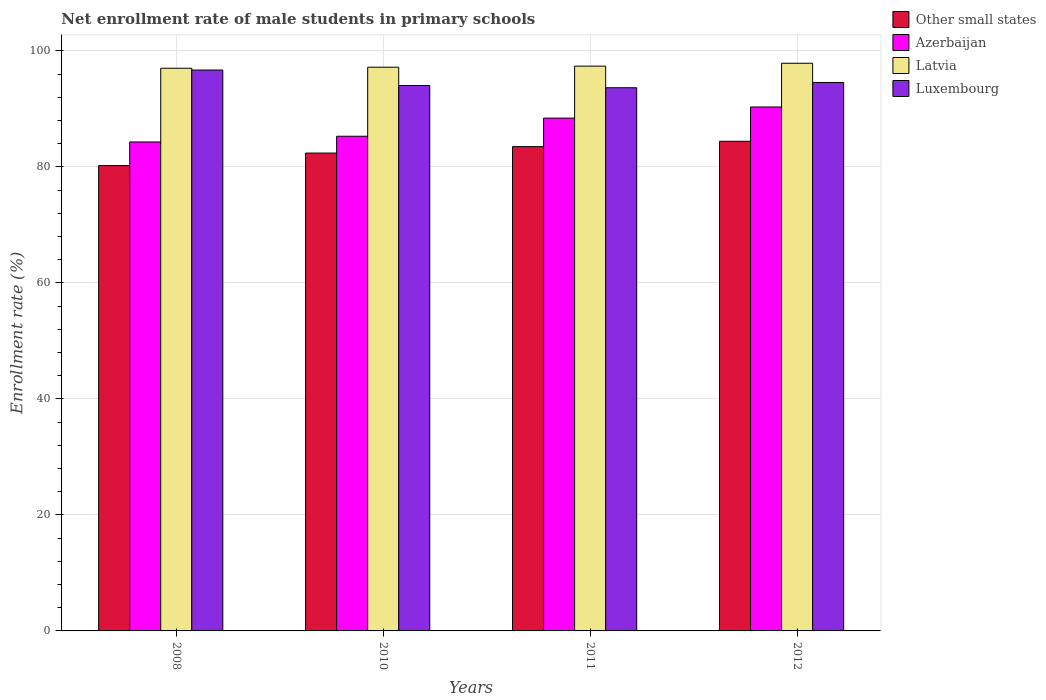How many different coloured bars are there?
Make the answer very short. 4. Are the number of bars per tick equal to the number of legend labels?
Offer a terse response. Yes. How many bars are there on the 2nd tick from the left?
Keep it short and to the point. 4. What is the label of the 2nd group of bars from the left?
Keep it short and to the point. 2010. In how many cases, is the number of bars for a given year not equal to the number of legend labels?
Make the answer very short. 0. What is the net enrollment rate of male students in primary schools in Other small states in 2012?
Offer a terse response. 84.41. Across all years, what is the maximum net enrollment rate of male students in primary schools in Other small states?
Ensure brevity in your answer.  84.41. Across all years, what is the minimum net enrollment rate of male students in primary schools in Azerbaijan?
Offer a very short reply. 84.3. In which year was the net enrollment rate of male students in primary schools in Latvia minimum?
Give a very brief answer. 2008. What is the total net enrollment rate of male students in primary schools in Other small states in the graph?
Keep it short and to the point. 330.5. What is the difference between the net enrollment rate of male students in primary schools in Azerbaijan in 2008 and that in 2010?
Your response must be concise. -0.98. What is the difference between the net enrollment rate of male students in primary schools in Azerbaijan in 2010 and the net enrollment rate of male students in primary schools in Other small states in 2012?
Offer a very short reply. 0.87. What is the average net enrollment rate of male students in primary schools in Luxembourg per year?
Ensure brevity in your answer.  94.73. In the year 2010, what is the difference between the net enrollment rate of male students in primary schools in Azerbaijan and net enrollment rate of male students in primary schools in Other small states?
Your answer should be very brief. 2.9. What is the ratio of the net enrollment rate of male students in primary schools in Azerbaijan in 2008 to that in 2011?
Offer a very short reply. 0.95. Is the net enrollment rate of male students in primary schools in Luxembourg in 2010 less than that in 2011?
Give a very brief answer. No. What is the difference between the highest and the second highest net enrollment rate of male students in primary schools in Other small states?
Ensure brevity in your answer.  0.92. What is the difference between the highest and the lowest net enrollment rate of male students in primary schools in Latvia?
Your answer should be very brief. 0.86. In how many years, is the net enrollment rate of male students in primary schools in Luxembourg greater than the average net enrollment rate of male students in primary schools in Luxembourg taken over all years?
Keep it short and to the point. 1. What does the 4th bar from the left in 2011 represents?
Make the answer very short. Luxembourg. What does the 4th bar from the right in 2011 represents?
Your response must be concise. Other small states. Is it the case that in every year, the sum of the net enrollment rate of male students in primary schools in Latvia and net enrollment rate of male students in primary schools in Other small states is greater than the net enrollment rate of male students in primary schools in Azerbaijan?
Your answer should be very brief. Yes. How many years are there in the graph?
Offer a very short reply. 4. What is the difference between two consecutive major ticks on the Y-axis?
Provide a succinct answer. 20. Does the graph contain any zero values?
Provide a succinct answer. No. Does the graph contain grids?
Give a very brief answer. Yes. How are the legend labels stacked?
Provide a succinct answer. Vertical. What is the title of the graph?
Ensure brevity in your answer.  Net enrollment rate of male students in primary schools. What is the label or title of the Y-axis?
Your answer should be compact. Enrollment rate (%). What is the Enrollment rate (%) of Other small states in 2008?
Make the answer very short. 80.22. What is the Enrollment rate (%) of Azerbaijan in 2008?
Your answer should be compact. 84.3. What is the Enrollment rate (%) of Latvia in 2008?
Offer a very short reply. 97. What is the Enrollment rate (%) in Luxembourg in 2008?
Offer a terse response. 96.69. What is the Enrollment rate (%) in Other small states in 2010?
Keep it short and to the point. 82.38. What is the Enrollment rate (%) of Azerbaijan in 2010?
Your answer should be very brief. 85.28. What is the Enrollment rate (%) of Latvia in 2010?
Provide a short and direct response. 97.18. What is the Enrollment rate (%) in Luxembourg in 2010?
Your response must be concise. 94.03. What is the Enrollment rate (%) of Other small states in 2011?
Keep it short and to the point. 83.49. What is the Enrollment rate (%) of Azerbaijan in 2011?
Ensure brevity in your answer.  88.41. What is the Enrollment rate (%) of Latvia in 2011?
Ensure brevity in your answer.  97.37. What is the Enrollment rate (%) in Luxembourg in 2011?
Your answer should be compact. 93.64. What is the Enrollment rate (%) of Other small states in 2012?
Keep it short and to the point. 84.41. What is the Enrollment rate (%) in Azerbaijan in 2012?
Provide a succinct answer. 90.33. What is the Enrollment rate (%) in Latvia in 2012?
Offer a very short reply. 97.86. What is the Enrollment rate (%) of Luxembourg in 2012?
Your answer should be compact. 94.55. Across all years, what is the maximum Enrollment rate (%) of Other small states?
Give a very brief answer. 84.41. Across all years, what is the maximum Enrollment rate (%) of Azerbaijan?
Your answer should be very brief. 90.33. Across all years, what is the maximum Enrollment rate (%) of Latvia?
Your answer should be compact. 97.86. Across all years, what is the maximum Enrollment rate (%) in Luxembourg?
Your response must be concise. 96.69. Across all years, what is the minimum Enrollment rate (%) of Other small states?
Offer a very short reply. 80.22. Across all years, what is the minimum Enrollment rate (%) in Azerbaijan?
Provide a short and direct response. 84.3. Across all years, what is the minimum Enrollment rate (%) of Latvia?
Your answer should be compact. 97. Across all years, what is the minimum Enrollment rate (%) of Luxembourg?
Your response must be concise. 93.64. What is the total Enrollment rate (%) of Other small states in the graph?
Ensure brevity in your answer.  330.5. What is the total Enrollment rate (%) in Azerbaijan in the graph?
Provide a short and direct response. 348.31. What is the total Enrollment rate (%) of Latvia in the graph?
Your answer should be very brief. 389.42. What is the total Enrollment rate (%) of Luxembourg in the graph?
Your answer should be very brief. 378.91. What is the difference between the Enrollment rate (%) in Other small states in 2008 and that in 2010?
Your answer should be compact. -2.16. What is the difference between the Enrollment rate (%) in Azerbaijan in 2008 and that in 2010?
Your answer should be compact. -0.98. What is the difference between the Enrollment rate (%) in Latvia in 2008 and that in 2010?
Ensure brevity in your answer.  -0.18. What is the difference between the Enrollment rate (%) in Luxembourg in 2008 and that in 2010?
Offer a very short reply. 2.66. What is the difference between the Enrollment rate (%) in Other small states in 2008 and that in 2011?
Give a very brief answer. -3.27. What is the difference between the Enrollment rate (%) in Azerbaijan in 2008 and that in 2011?
Make the answer very short. -4.11. What is the difference between the Enrollment rate (%) of Latvia in 2008 and that in 2011?
Make the answer very short. -0.36. What is the difference between the Enrollment rate (%) in Luxembourg in 2008 and that in 2011?
Your answer should be very brief. 3.05. What is the difference between the Enrollment rate (%) of Other small states in 2008 and that in 2012?
Your answer should be very brief. -4.2. What is the difference between the Enrollment rate (%) in Azerbaijan in 2008 and that in 2012?
Offer a terse response. -6.03. What is the difference between the Enrollment rate (%) of Latvia in 2008 and that in 2012?
Provide a short and direct response. -0.86. What is the difference between the Enrollment rate (%) of Luxembourg in 2008 and that in 2012?
Provide a succinct answer. 2.14. What is the difference between the Enrollment rate (%) in Other small states in 2010 and that in 2011?
Keep it short and to the point. -1.11. What is the difference between the Enrollment rate (%) of Azerbaijan in 2010 and that in 2011?
Give a very brief answer. -3.13. What is the difference between the Enrollment rate (%) of Latvia in 2010 and that in 2011?
Your response must be concise. -0.19. What is the difference between the Enrollment rate (%) of Luxembourg in 2010 and that in 2011?
Give a very brief answer. 0.39. What is the difference between the Enrollment rate (%) of Other small states in 2010 and that in 2012?
Offer a very short reply. -2.03. What is the difference between the Enrollment rate (%) in Azerbaijan in 2010 and that in 2012?
Make the answer very short. -5.05. What is the difference between the Enrollment rate (%) in Latvia in 2010 and that in 2012?
Keep it short and to the point. -0.68. What is the difference between the Enrollment rate (%) in Luxembourg in 2010 and that in 2012?
Offer a terse response. -0.52. What is the difference between the Enrollment rate (%) in Other small states in 2011 and that in 2012?
Make the answer very short. -0.92. What is the difference between the Enrollment rate (%) in Azerbaijan in 2011 and that in 2012?
Provide a short and direct response. -1.92. What is the difference between the Enrollment rate (%) of Latvia in 2011 and that in 2012?
Your response must be concise. -0.5. What is the difference between the Enrollment rate (%) in Luxembourg in 2011 and that in 2012?
Keep it short and to the point. -0.91. What is the difference between the Enrollment rate (%) in Other small states in 2008 and the Enrollment rate (%) in Azerbaijan in 2010?
Give a very brief answer. -5.06. What is the difference between the Enrollment rate (%) in Other small states in 2008 and the Enrollment rate (%) in Latvia in 2010?
Make the answer very short. -16.96. What is the difference between the Enrollment rate (%) in Other small states in 2008 and the Enrollment rate (%) in Luxembourg in 2010?
Give a very brief answer. -13.81. What is the difference between the Enrollment rate (%) in Azerbaijan in 2008 and the Enrollment rate (%) in Latvia in 2010?
Make the answer very short. -12.89. What is the difference between the Enrollment rate (%) in Azerbaijan in 2008 and the Enrollment rate (%) in Luxembourg in 2010?
Your response must be concise. -9.73. What is the difference between the Enrollment rate (%) in Latvia in 2008 and the Enrollment rate (%) in Luxembourg in 2010?
Provide a succinct answer. 2.97. What is the difference between the Enrollment rate (%) in Other small states in 2008 and the Enrollment rate (%) in Azerbaijan in 2011?
Your response must be concise. -8.19. What is the difference between the Enrollment rate (%) of Other small states in 2008 and the Enrollment rate (%) of Latvia in 2011?
Make the answer very short. -17.15. What is the difference between the Enrollment rate (%) in Other small states in 2008 and the Enrollment rate (%) in Luxembourg in 2011?
Keep it short and to the point. -13.42. What is the difference between the Enrollment rate (%) of Azerbaijan in 2008 and the Enrollment rate (%) of Latvia in 2011?
Your answer should be compact. -13.07. What is the difference between the Enrollment rate (%) of Azerbaijan in 2008 and the Enrollment rate (%) of Luxembourg in 2011?
Provide a succinct answer. -9.35. What is the difference between the Enrollment rate (%) of Latvia in 2008 and the Enrollment rate (%) of Luxembourg in 2011?
Offer a terse response. 3.36. What is the difference between the Enrollment rate (%) of Other small states in 2008 and the Enrollment rate (%) of Azerbaijan in 2012?
Provide a succinct answer. -10.11. What is the difference between the Enrollment rate (%) in Other small states in 2008 and the Enrollment rate (%) in Latvia in 2012?
Your answer should be very brief. -17.64. What is the difference between the Enrollment rate (%) in Other small states in 2008 and the Enrollment rate (%) in Luxembourg in 2012?
Provide a succinct answer. -14.33. What is the difference between the Enrollment rate (%) of Azerbaijan in 2008 and the Enrollment rate (%) of Latvia in 2012?
Give a very brief answer. -13.57. What is the difference between the Enrollment rate (%) in Azerbaijan in 2008 and the Enrollment rate (%) in Luxembourg in 2012?
Your answer should be compact. -10.25. What is the difference between the Enrollment rate (%) in Latvia in 2008 and the Enrollment rate (%) in Luxembourg in 2012?
Offer a very short reply. 2.46. What is the difference between the Enrollment rate (%) in Other small states in 2010 and the Enrollment rate (%) in Azerbaijan in 2011?
Your answer should be compact. -6.02. What is the difference between the Enrollment rate (%) in Other small states in 2010 and the Enrollment rate (%) in Latvia in 2011?
Give a very brief answer. -14.99. What is the difference between the Enrollment rate (%) of Other small states in 2010 and the Enrollment rate (%) of Luxembourg in 2011?
Your answer should be compact. -11.26. What is the difference between the Enrollment rate (%) in Azerbaijan in 2010 and the Enrollment rate (%) in Latvia in 2011?
Provide a succinct answer. -12.09. What is the difference between the Enrollment rate (%) of Azerbaijan in 2010 and the Enrollment rate (%) of Luxembourg in 2011?
Your answer should be very brief. -8.36. What is the difference between the Enrollment rate (%) of Latvia in 2010 and the Enrollment rate (%) of Luxembourg in 2011?
Your answer should be compact. 3.54. What is the difference between the Enrollment rate (%) in Other small states in 2010 and the Enrollment rate (%) in Azerbaijan in 2012?
Your answer should be very brief. -7.94. What is the difference between the Enrollment rate (%) in Other small states in 2010 and the Enrollment rate (%) in Latvia in 2012?
Your response must be concise. -15.48. What is the difference between the Enrollment rate (%) of Other small states in 2010 and the Enrollment rate (%) of Luxembourg in 2012?
Your response must be concise. -12.17. What is the difference between the Enrollment rate (%) in Azerbaijan in 2010 and the Enrollment rate (%) in Latvia in 2012?
Offer a terse response. -12.58. What is the difference between the Enrollment rate (%) in Azerbaijan in 2010 and the Enrollment rate (%) in Luxembourg in 2012?
Give a very brief answer. -9.27. What is the difference between the Enrollment rate (%) in Latvia in 2010 and the Enrollment rate (%) in Luxembourg in 2012?
Your answer should be compact. 2.63. What is the difference between the Enrollment rate (%) in Other small states in 2011 and the Enrollment rate (%) in Azerbaijan in 2012?
Keep it short and to the point. -6.83. What is the difference between the Enrollment rate (%) in Other small states in 2011 and the Enrollment rate (%) in Latvia in 2012?
Your answer should be very brief. -14.37. What is the difference between the Enrollment rate (%) in Other small states in 2011 and the Enrollment rate (%) in Luxembourg in 2012?
Provide a short and direct response. -11.06. What is the difference between the Enrollment rate (%) in Azerbaijan in 2011 and the Enrollment rate (%) in Latvia in 2012?
Offer a terse response. -9.46. What is the difference between the Enrollment rate (%) of Azerbaijan in 2011 and the Enrollment rate (%) of Luxembourg in 2012?
Offer a very short reply. -6.14. What is the difference between the Enrollment rate (%) in Latvia in 2011 and the Enrollment rate (%) in Luxembourg in 2012?
Give a very brief answer. 2.82. What is the average Enrollment rate (%) in Other small states per year?
Your answer should be very brief. 82.63. What is the average Enrollment rate (%) of Azerbaijan per year?
Provide a succinct answer. 87.08. What is the average Enrollment rate (%) in Latvia per year?
Your answer should be compact. 97.35. What is the average Enrollment rate (%) of Luxembourg per year?
Give a very brief answer. 94.73. In the year 2008, what is the difference between the Enrollment rate (%) in Other small states and Enrollment rate (%) in Azerbaijan?
Provide a short and direct response. -4.08. In the year 2008, what is the difference between the Enrollment rate (%) of Other small states and Enrollment rate (%) of Latvia?
Make the answer very short. -16.79. In the year 2008, what is the difference between the Enrollment rate (%) in Other small states and Enrollment rate (%) in Luxembourg?
Offer a very short reply. -16.48. In the year 2008, what is the difference between the Enrollment rate (%) of Azerbaijan and Enrollment rate (%) of Latvia?
Offer a very short reply. -12.71. In the year 2008, what is the difference between the Enrollment rate (%) of Azerbaijan and Enrollment rate (%) of Luxembourg?
Your answer should be very brief. -12.4. In the year 2008, what is the difference between the Enrollment rate (%) in Latvia and Enrollment rate (%) in Luxembourg?
Offer a very short reply. 0.31. In the year 2010, what is the difference between the Enrollment rate (%) of Other small states and Enrollment rate (%) of Azerbaijan?
Give a very brief answer. -2.9. In the year 2010, what is the difference between the Enrollment rate (%) in Other small states and Enrollment rate (%) in Latvia?
Your response must be concise. -14.8. In the year 2010, what is the difference between the Enrollment rate (%) in Other small states and Enrollment rate (%) in Luxembourg?
Give a very brief answer. -11.65. In the year 2010, what is the difference between the Enrollment rate (%) in Azerbaijan and Enrollment rate (%) in Latvia?
Your answer should be very brief. -11.9. In the year 2010, what is the difference between the Enrollment rate (%) in Azerbaijan and Enrollment rate (%) in Luxembourg?
Your answer should be very brief. -8.75. In the year 2010, what is the difference between the Enrollment rate (%) in Latvia and Enrollment rate (%) in Luxembourg?
Make the answer very short. 3.15. In the year 2011, what is the difference between the Enrollment rate (%) of Other small states and Enrollment rate (%) of Azerbaijan?
Give a very brief answer. -4.91. In the year 2011, what is the difference between the Enrollment rate (%) in Other small states and Enrollment rate (%) in Latvia?
Give a very brief answer. -13.88. In the year 2011, what is the difference between the Enrollment rate (%) in Other small states and Enrollment rate (%) in Luxembourg?
Ensure brevity in your answer.  -10.15. In the year 2011, what is the difference between the Enrollment rate (%) of Azerbaijan and Enrollment rate (%) of Latvia?
Offer a terse response. -8.96. In the year 2011, what is the difference between the Enrollment rate (%) in Azerbaijan and Enrollment rate (%) in Luxembourg?
Ensure brevity in your answer.  -5.24. In the year 2011, what is the difference between the Enrollment rate (%) in Latvia and Enrollment rate (%) in Luxembourg?
Your response must be concise. 3.73. In the year 2012, what is the difference between the Enrollment rate (%) in Other small states and Enrollment rate (%) in Azerbaijan?
Your response must be concise. -5.91. In the year 2012, what is the difference between the Enrollment rate (%) of Other small states and Enrollment rate (%) of Latvia?
Offer a terse response. -13.45. In the year 2012, what is the difference between the Enrollment rate (%) in Other small states and Enrollment rate (%) in Luxembourg?
Make the answer very short. -10.14. In the year 2012, what is the difference between the Enrollment rate (%) of Azerbaijan and Enrollment rate (%) of Latvia?
Ensure brevity in your answer.  -7.54. In the year 2012, what is the difference between the Enrollment rate (%) of Azerbaijan and Enrollment rate (%) of Luxembourg?
Provide a short and direct response. -4.22. In the year 2012, what is the difference between the Enrollment rate (%) of Latvia and Enrollment rate (%) of Luxembourg?
Make the answer very short. 3.31. What is the ratio of the Enrollment rate (%) in Other small states in 2008 to that in 2010?
Ensure brevity in your answer.  0.97. What is the ratio of the Enrollment rate (%) of Azerbaijan in 2008 to that in 2010?
Provide a short and direct response. 0.99. What is the ratio of the Enrollment rate (%) of Latvia in 2008 to that in 2010?
Keep it short and to the point. 1. What is the ratio of the Enrollment rate (%) of Luxembourg in 2008 to that in 2010?
Make the answer very short. 1.03. What is the ratio of the Enrollment rate (%) of Other small states in 2008 to that in 2011?
Provide a short and direct response. 0.96. What is the ratio of the Enrollment rate (%) in Azerbaijan in 2008 to that in 2011?
Your response must be concise. 0.95. What is the ratio of the Enrollment rate (%) of Latvia in 2008 to that in 2011?
Offer a very short reply. 1. What is the ratio of the Enrollment rate (%) of Luxembourg in 2008 to that in 2011?
Make the answer very short. 1.03. What is the ratio of the Enrollment rate (%) in Other small states in 2008 to that in 2012?
Provide a short and direct response. 0.95. What is the ratio of the Enrollment rate (%) in Azerbaijan in 2008 to that in 2012?
Ensure brevity in your answer.  0.93. What is the ratio of the Enrollment rate (%) in Luxembourg in 2008 to that in 2012?
Offer a terse response. 1.02. What is the ratio of the Enrollment rate (%) in Other small states in 2010 to that in 2011?
Ensure brevity in your answer.  0.99. What is the ratio of the Enrollment rate (%) of Azerbaijan in 2010 to that in 2011?
Your response must be concise. 0.96. What is the ratio of the Enrollment rate (%) in Latvia in 2010 to that in 2011?
Ensure brevity in your answer.  1. What is the ratio of the Enrollment rate (%) in Other small states in 2010 to that in 2012?
Give a very brief answer. 0.98. What is the ratio of the Enrollment rate (%) in Azerbaijan in 2010 to that in 2012?
Offer a terse response. 0.94. What is the ratio of the Enrollment rate (%) in Latvia in 2010 to that in 2012?
Your answer should be compact. 0.99. What is the ratio of the Enrollment rate (%) in Luxembourg in 2010 to that in 2012?
Provide a succinct answer. 0.99. What is the ratio of the Enrollment rate (%) of Azerbaijan in 2011 to that in 2012?
Give a very brief answer. 0.98. What is the ratio of the Enrollment rate (%) in Luxembourg in 2011 to that in 2012?
Provide a succinct answer. 0.99. What is the difference between the highest and the second highest Enrollment rate (%) of Other small states?
Make the answer very short. 0.92. What is the difference between the highest and the second highest Enrollment rate (%) in Azerbaijan?
Your response must be concise. 1.92. What is the difference between the highest and the second highest Enrollment rate (%) in Latvia?
Your answer should be compact. 0.5. What is the difference between the highest and the second highest Enrollment rate (%) in Luxembourg?
Provide a succinct answer. 2.14. What is the difference between the highest and the lowest Enrollment rate (%) in Other small states?
Make the answer very short. 4.2. What is the difference between the highest and the lowest Enrollment rate (%) of Azerbaijan?
Ensure brevity in your answer.  6.03. What is the difference between the highest and the lowest Enrollment rate (%) of Latvia?
Offer a very short reply. 0.86. What is the difference between the highest and the lowest Enrollment rate (%) in Luxembourg?
Ensure brevity in your answer.  3.05. 